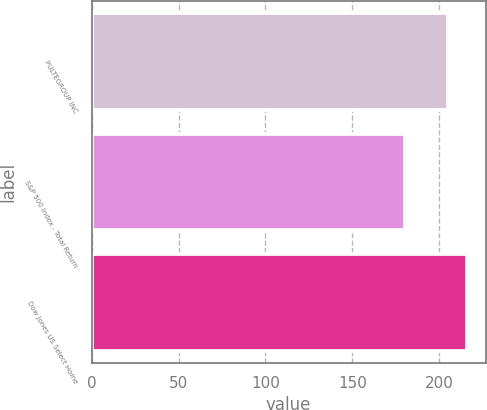<chart> <loc_0><loc_0><loc_500><loc_500><bar_chart><fcel>PULTEGROUP INC<fcel>S&P 500 Index - Total Return<fcel>Dow Jones US Select Home<nl><fcel>205.2<fcel>180.44<fcel>215.76<nl></chart> 